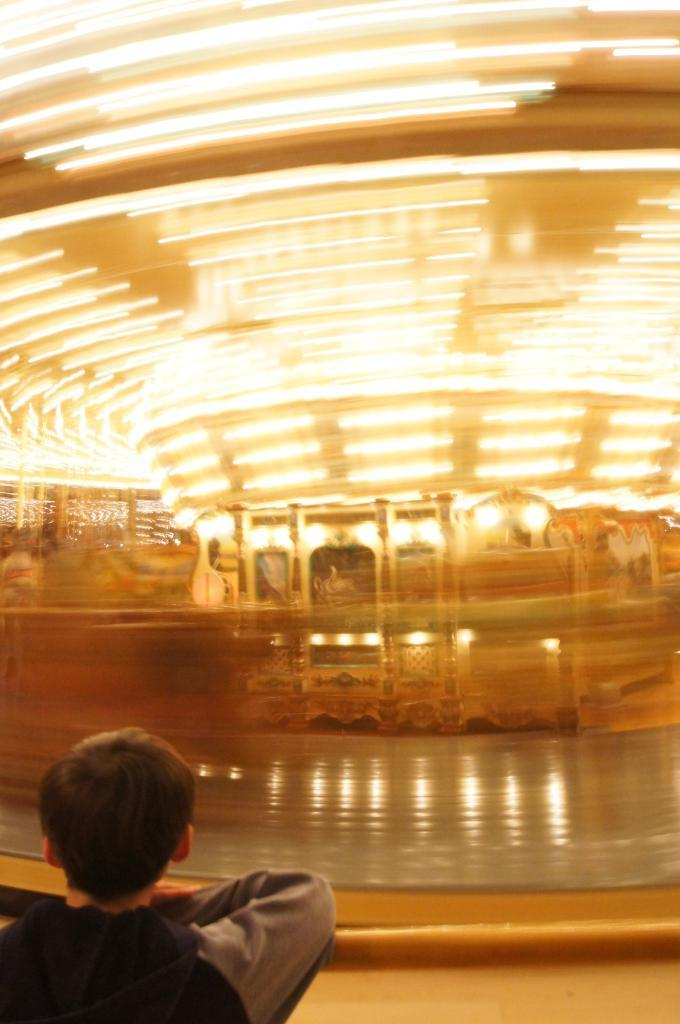Who or what is in the image? There is a person in the image. What is the person doing in the image? The person is standing over a place. What can be seen in the background of the image? There is a pool filled with water in the image, and it is in front of the person. What else is visible in the image? There are lights present on the roof in the image. What type of knife is being used to improve the acoustics in the image? There is no knife or mention of acoustics in the image; it features a person standing over a pool with lights on the roof. 